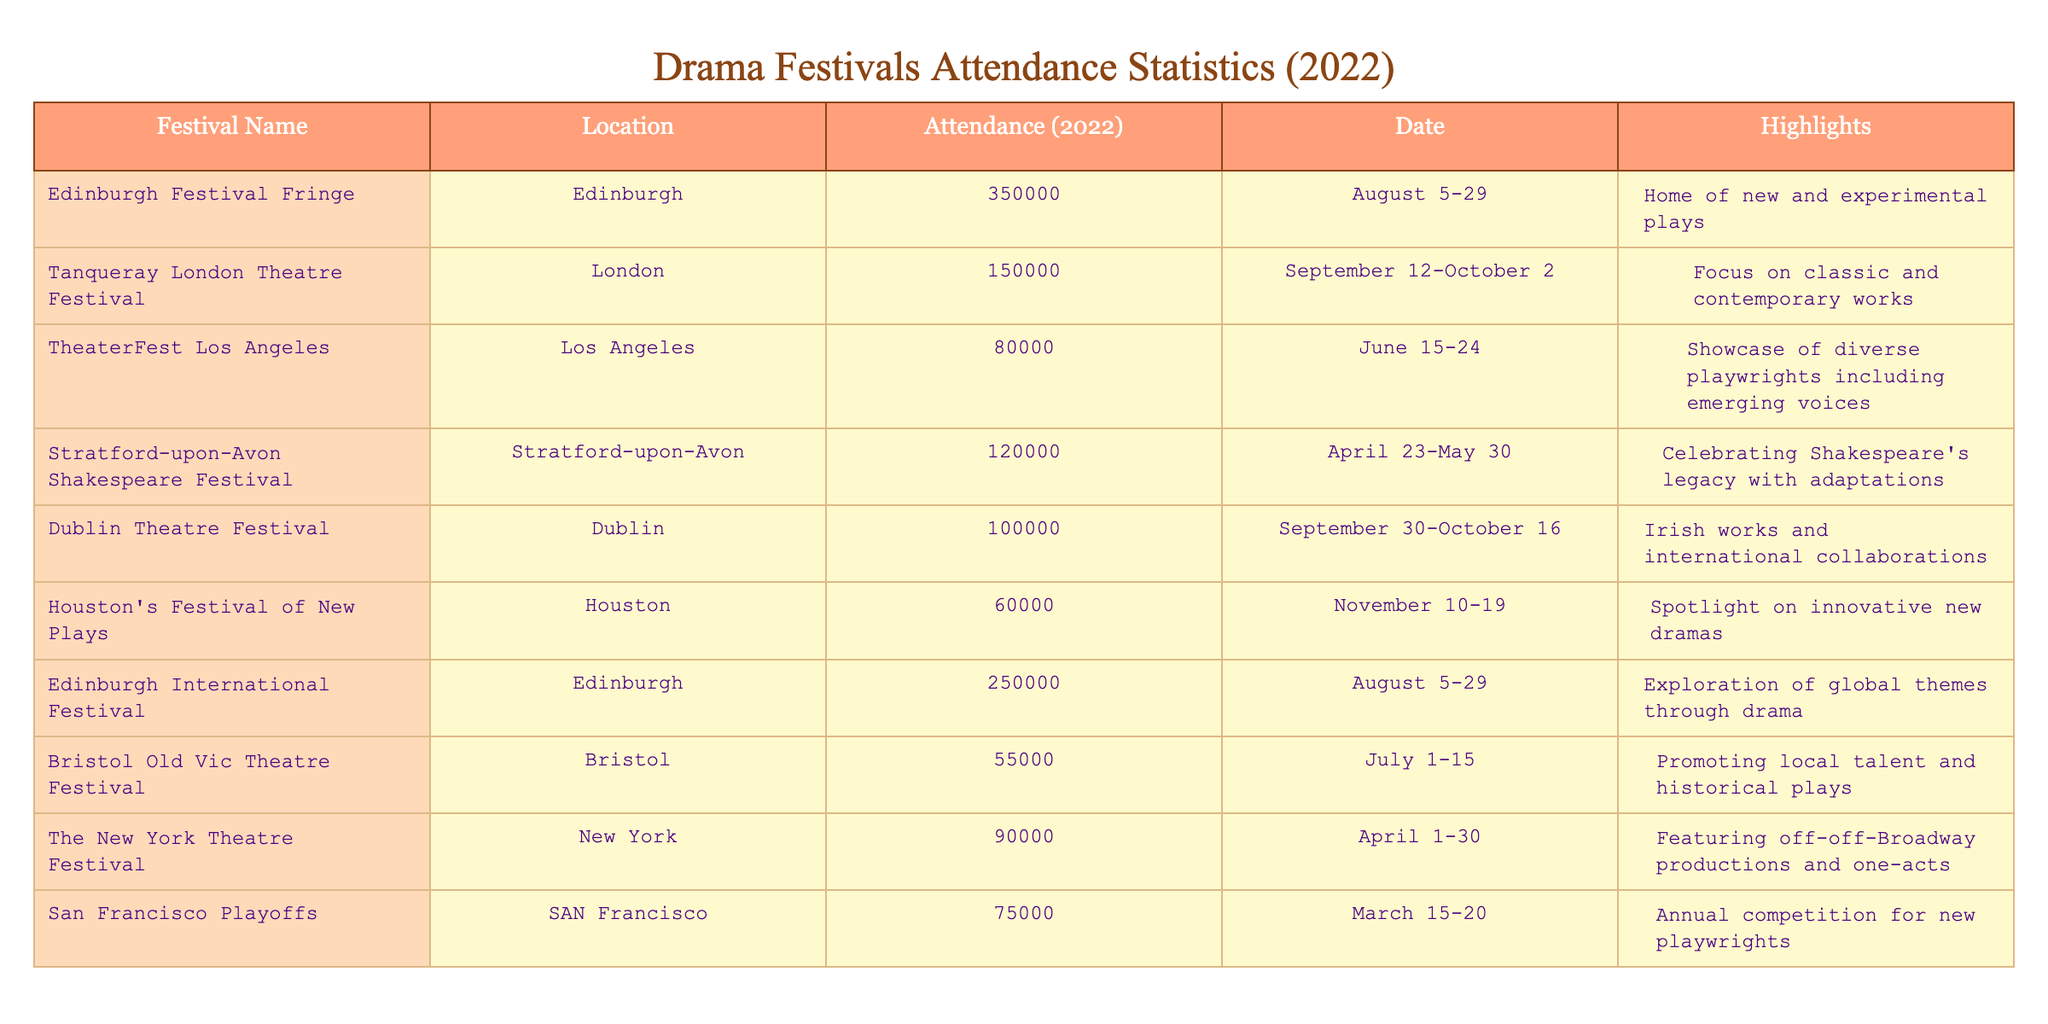What is the attendance of the Edinburgh Festival Fringe in 2022? The table explicitly states that the attendance for the Edinburgh Festival Fringe in 2022 is 350,000.
Answer: 350,000 Which festival had the least attendance in 2022? By reviewing the attendance figures, the Bristol Old Vic Theatre Festival had the least attendance of 55,000.
Answer: 55,000 What is the total attendance of both Edinburgh festivals? The attendance for the Edinburgh Festival Fringe is 350,000 and for the Edinburgh International Festival, it is 250,000. Adding them gives 350,000 + 250,000 = 600,000.
Answer: 600,000 Is the Tanqueray London Theatre Festival located in Dublin? The table shows that the Tanqueray London Theatre Festival is located in London, not Dublin.
Answer: No What is the average attendance of the festivals held in August? The festivals in August are the Edinburgh Festival Fringe (350,000) and the Edinburgh International Festival (250,000). Their average is (350,000 + 250,000) / 2 = 300,000.
Answer: 300,000 What is the difference in attendance between the Houston's Festival of New Plays and the TheaterFest Los Angeles? The attendance for Houston's Festival of New Plays is 60,000, and for TheaterFest Los Angeles, it is 80,000. The difference is 80,000 - 60,000 = 20,000.
Answer: 20,000 Which festival celebrates Shakespeare's legacy? The Stratford-upon-Avon Shakespeare Festival is noted in the table for celebrating Shakespeare's legacy with adaptations.
Answer: Stratford-upon-Avon Shakespeare Festival What is the total attendance for all listed festivals in 2022? Summing the attendance figures of all festivals gives: 350,000 + 150,000 + 80,000 + 120,000 + 100,000 + 60,000 + 250,000 + 55,000 + 90,000 + 75,000 = 1,030,000.
Answer: 1,030,000 How many festivals had an attendance of over 100,000? The festivals with attendance over 100,000 are the Edinburgh Festival Fringe, Edinburgh International Festival, Tanqueray London Theatre Festival, and Stratford-upon-Avon Shakespeare Festival. This totals four festivals.
Answer: 4 Did any festival occur in September? The table lists two festivals occurring in September: the Tanqueray London Theatre Festival and the Dublin Theatre Festival.
Answer: Yes 